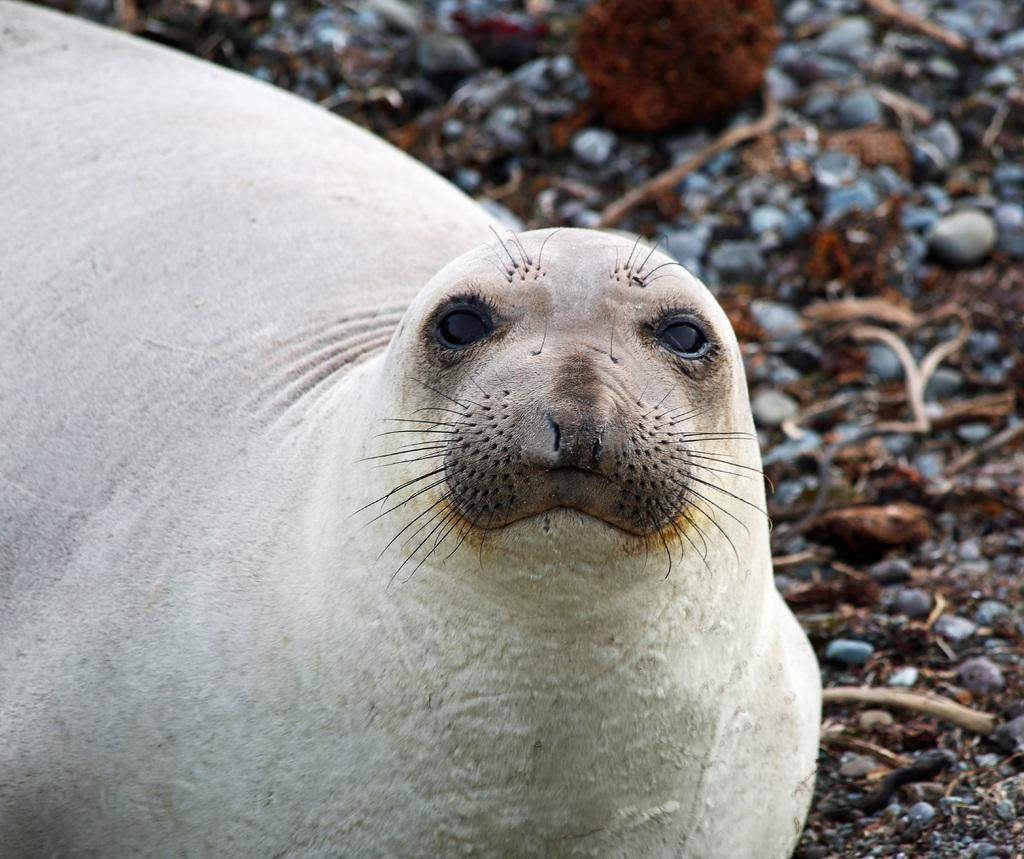What type of animal is in the image? There is a seal fish in the image. Can you describe the background of the image? The background of the image is blurred. What type of lamp is used by the men in the winter scene in the image? There are no men, winter scene, or lamp present in the image; it only features a seal fish with a blurred background. 